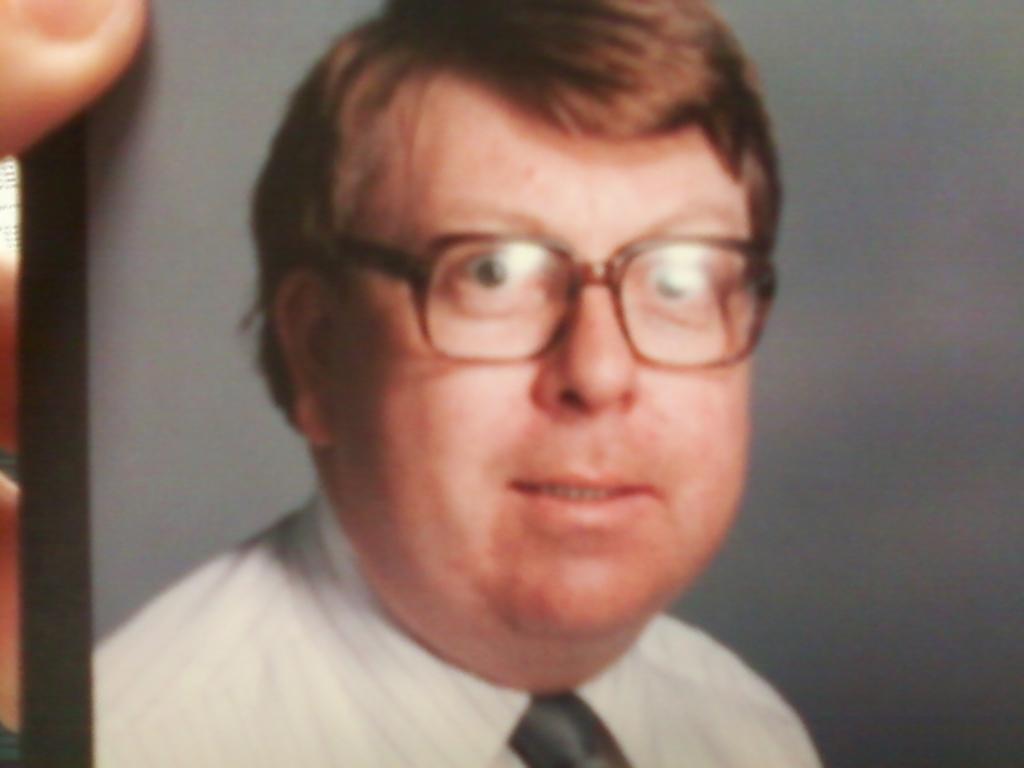In one or two sentences, can you explain what this image depicts? In this image, we can see photo of a picture. There is a person in the middle of the image wearing clothes and spectacles. 